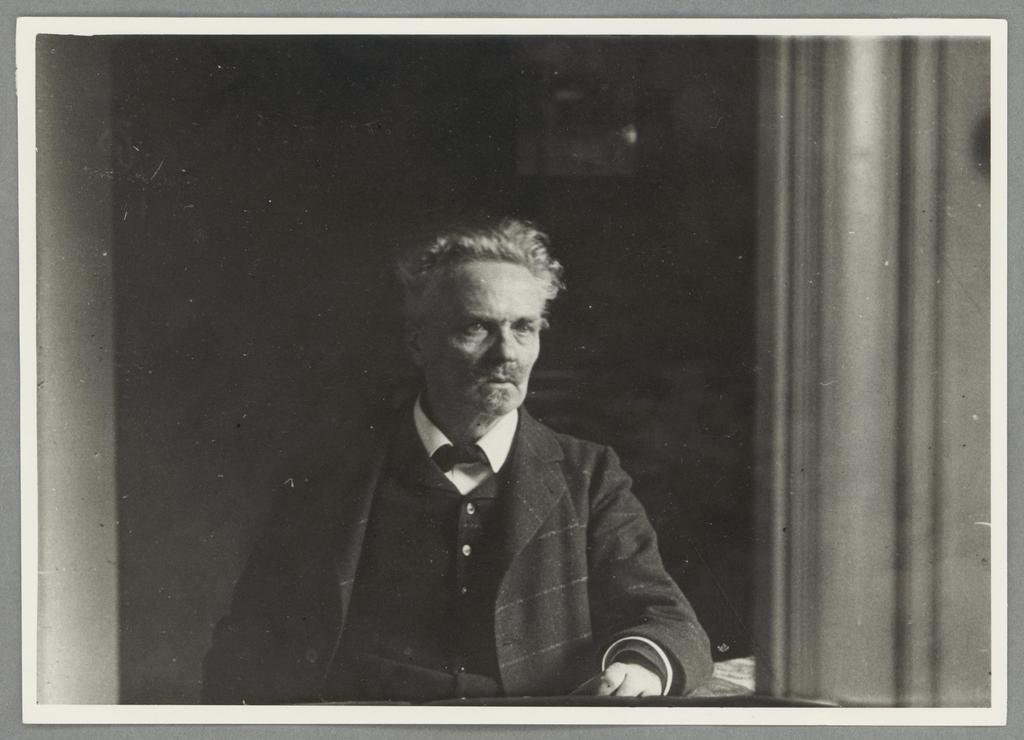What is the main subject of the image? There is a photograph in the image. Can you describe the person in the image? There is a person in the image. What can be seen in the background of the person? The background of the person is dark, and there is a wall visible in the background of the image. What type of smoke is coming from the person's mouth in the image? There is no smoke coming from the person's mouth in the image. What color is the ink used to write on the wall in the image? There is no writing or ink present on the wall in the image. 